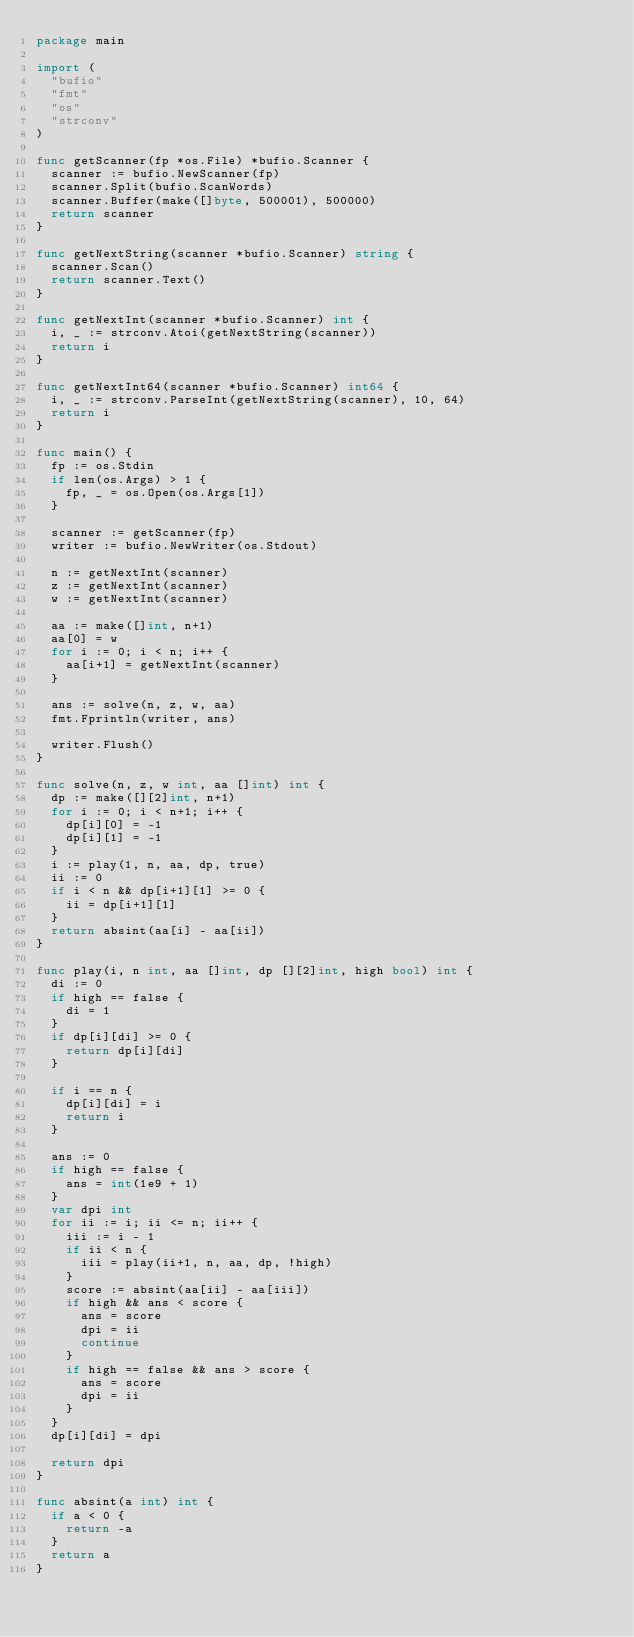<code> <loc_0><loc_0><loc_500><loc_500><_Go_>package main

import (
	"bufio"
	"fmt"
	"os"
	"strconv"
)

func getScanner(fp *os.File) *bufio.Scanner {
	scanner := bufio.NewScanner(fp)
	scanner.Split(bufio.ScanWords)
	scanner.Buffer(make([]byte, 500001), 500000)
	return scanner
}

func getNextString(scanner *bufio.Scanner) string {
	scanner.Scan()
	return scanner.Text()
}

func getNextInt(scanner *bufio.Scanner) int {
	i, _ := strconv.Atoi(getNextString(scanner))
	return i
}

func getNextInt64(scanner *bufio.Scanner) int64 {
	i, _ := strconv.ParseInt(getNextString(scanner), 10, 64)
	return i
}

func main() {
	fp := os.Stdin
	if len(os.Args) > 1 {
		fp, _ = os.Open(os.Args[1])
	}

	scanner := getScanner(fp)
	writer := bufio.NewWriter(os.Stdout)

	n := getNextInt(scanner)
	z := getNextInt(scanner)
	w := getNextInt(scanner)

	aa := make([]int, n+1)
	aa[0] = w
	for i := 0; i < n; i++ {
		aa[i+1] = getNextInt(scanner)
	}

	ans := solve(n, z, w, aa)
	fmt.Fprintln(writer, ans)

	writer.Flush()
}

func solve(n, z, w int, aa []int) int {
	dp := make([][2]int, n+1)
	for i := 0; i < n+1; i++ {
		dp[i][0] = -1
		dp[i][1] = -1
	}
	i := play(1, n, aa, dp, true)
	ii := 0
	if i < n && dp[i+1][1] >= 0 {
		ii = dp[i+1][1]
	}
	return absint(aa[i] - aa[ii])
}

func play(i, n int, aa []int, dp [][2]int, high bool) int {
	di := 0
	if high == false {
		di = 1
	}
	if dp[i][di] >= 0 {
		return dp[i][di]
	}

	if i == n {
		dp[i][di] = i
		return i
	}

	ans := 0
	if high == false {
		ans = int(1e9 + 1)
	}
	var dpi int
	for ii := i; ii <= n; ii++ {
		iii := i - 1
		if ii < n {
			iii = play(ii+1, n, aa, dp, !high)
		}
		score := absint(aa[ii] - aa[iii])
		if high && ans < score {
			ans = score
			dpi = ii
			continue
		}
		if high == false && ans > score {
			ans = score
			dpi = ii
		}
	}
	dp[i][di] = dpi

	return dpi
}

func absint(a int) int {
	if a < 0 {
		return -a
	}
	return a
}
</code> 